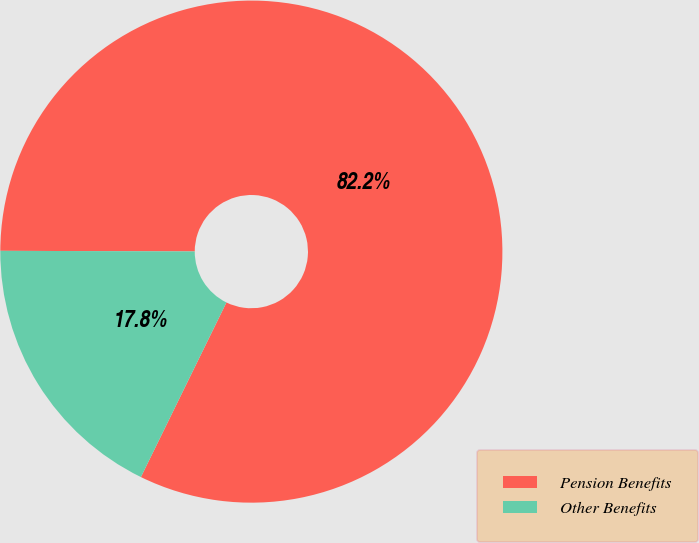Convert chart. <chart><loc_0><loc_0><loc_500><loc_500><pie_chart><fcel>Pension Benefits<fcel>Other Benefits<nl><fcel>82.2%<fcel>17.8%<nl></chart> 